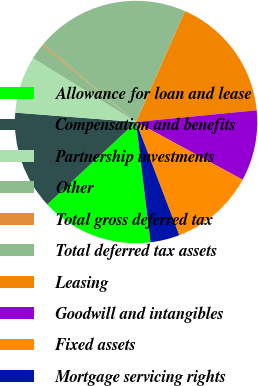Convert chart. <chart><loc_0><loc_0><loc_500><loc_500><pie_chart><fcel>Allowance for loan and lease<fcel>Compensation and benefits<fcel>Partnership investments<fcel>Other<fcel>Total gross deferred tax<fcel>Total deferred tax assets<fcel>Leasing<fcel>Goodwill and intangibles<fcel>Fixed assets<fcel>Mortgage servicing rights<nl><fcel>14.99%<fcel>13.14%<fcel>7.6%<fcel>2.05%<fcel>0.2%<fcel>20.54%<fcel>16.84%<fcel>9.45%<fcel>11.29%<fcel>3.9%<nl></chart> 